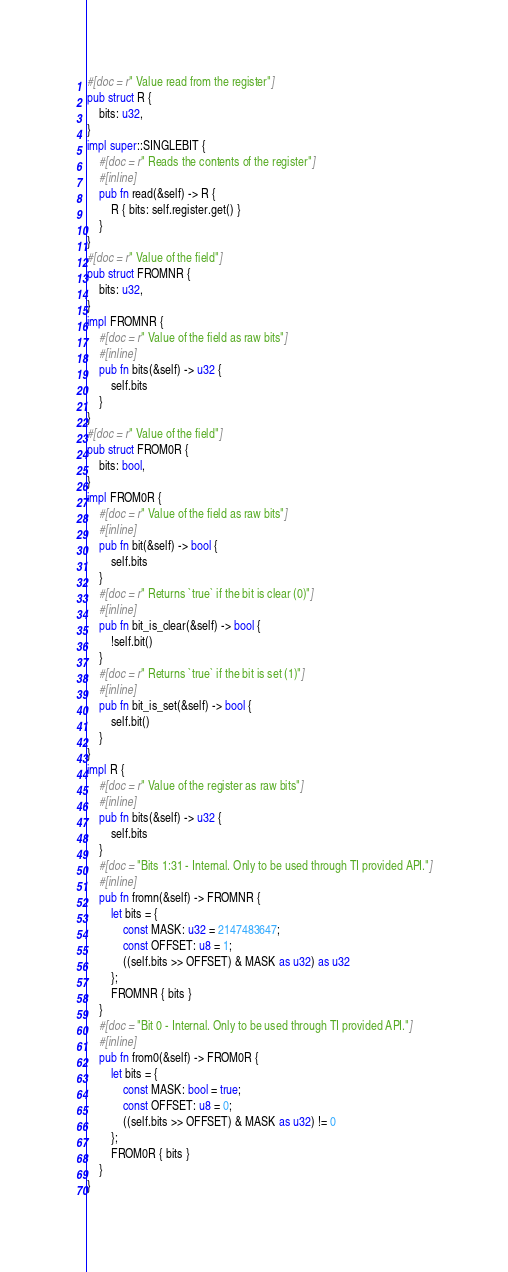Convert code to text. <code><loc_0><loc_0><loc_500><loc_500><_Rust_>#[doc = r" Value read from the register"]
pub struct R {
    bits: u32,
}
impl super::SINGLEBIT {
    #[doc = r" Reads the contents of the register"]
    #[inline]
    pub fn read(&self) -> R {
        R { bits: self.register.get() }
    }
}
#[doc = r" Value of the field"]
pub struct FROMNR {
    bits: u32,
}
impl FROMNR {
    #[doc = r" Value of the field as raw bits"]
    #[inline]
    pub fn bits(&self) -> u32 {
        self.bits
    }
}
#[doc = r" Value of the field"]
pub struct FROM0R {
    bits: bool,
}
impl FROM0R {
    #[doc = r" Value of the field as raw bits"]
    #[inline]
    pub fn bit(&self) -> bool {
        self.bits
    }
    #[doc = r" Returns `true` if the bit is clear (0)"]
    #[inline]
    pub fn bit_is_clear(&self) -> bool {
        !self.bit()
    }
    #[doc = r" Returns `true` if the bit is set (1)"]
    #[inline]
    pub fn bit_is_set(&self) -> bool {
        self.bit()
    }
}
impl R {
    #[doc = r" Value of the register as raw bits"]
    #[inline]
    pub fn bits(&self) -> u32 {
        self.bits
    }
    #[doc = "Bits 1:31 - Internal. Only to be used through TI provided API."]
    #[inline]
    pub fn fromn(&self) -> FROMNR {
        let bits = {
            const MASK: u32 = 2147483647;
            const OFFSET: u8 = 1;
            ((self.bits >> OFFSET) & MASK as u32) as u32
        };
        FROMNR { bits }
    }
    #[doc = "Bit 0 - Internal. Only to be used through TI provided API."]
    #[inline]
    pub fn from0(&self) -> FROM0R {
        let bits = {
            const MASK: bool = true;
            const OFFSET: u8 = 0;
            ((self.bits >> OFFSET) & MASK as u32) != 0
        };
        FROM0R { bits }
    }
}
</code> 